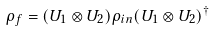<formula> <loc_0><loc_0><loc_500><loc_500>\rho _ { f } = ( U _ { 1 } \otimes U _ { 2 } ) \rho _ { i n } ( U _ { 1 } \otimes U _ { 2 } ) ^ { \dagger }</formula> 